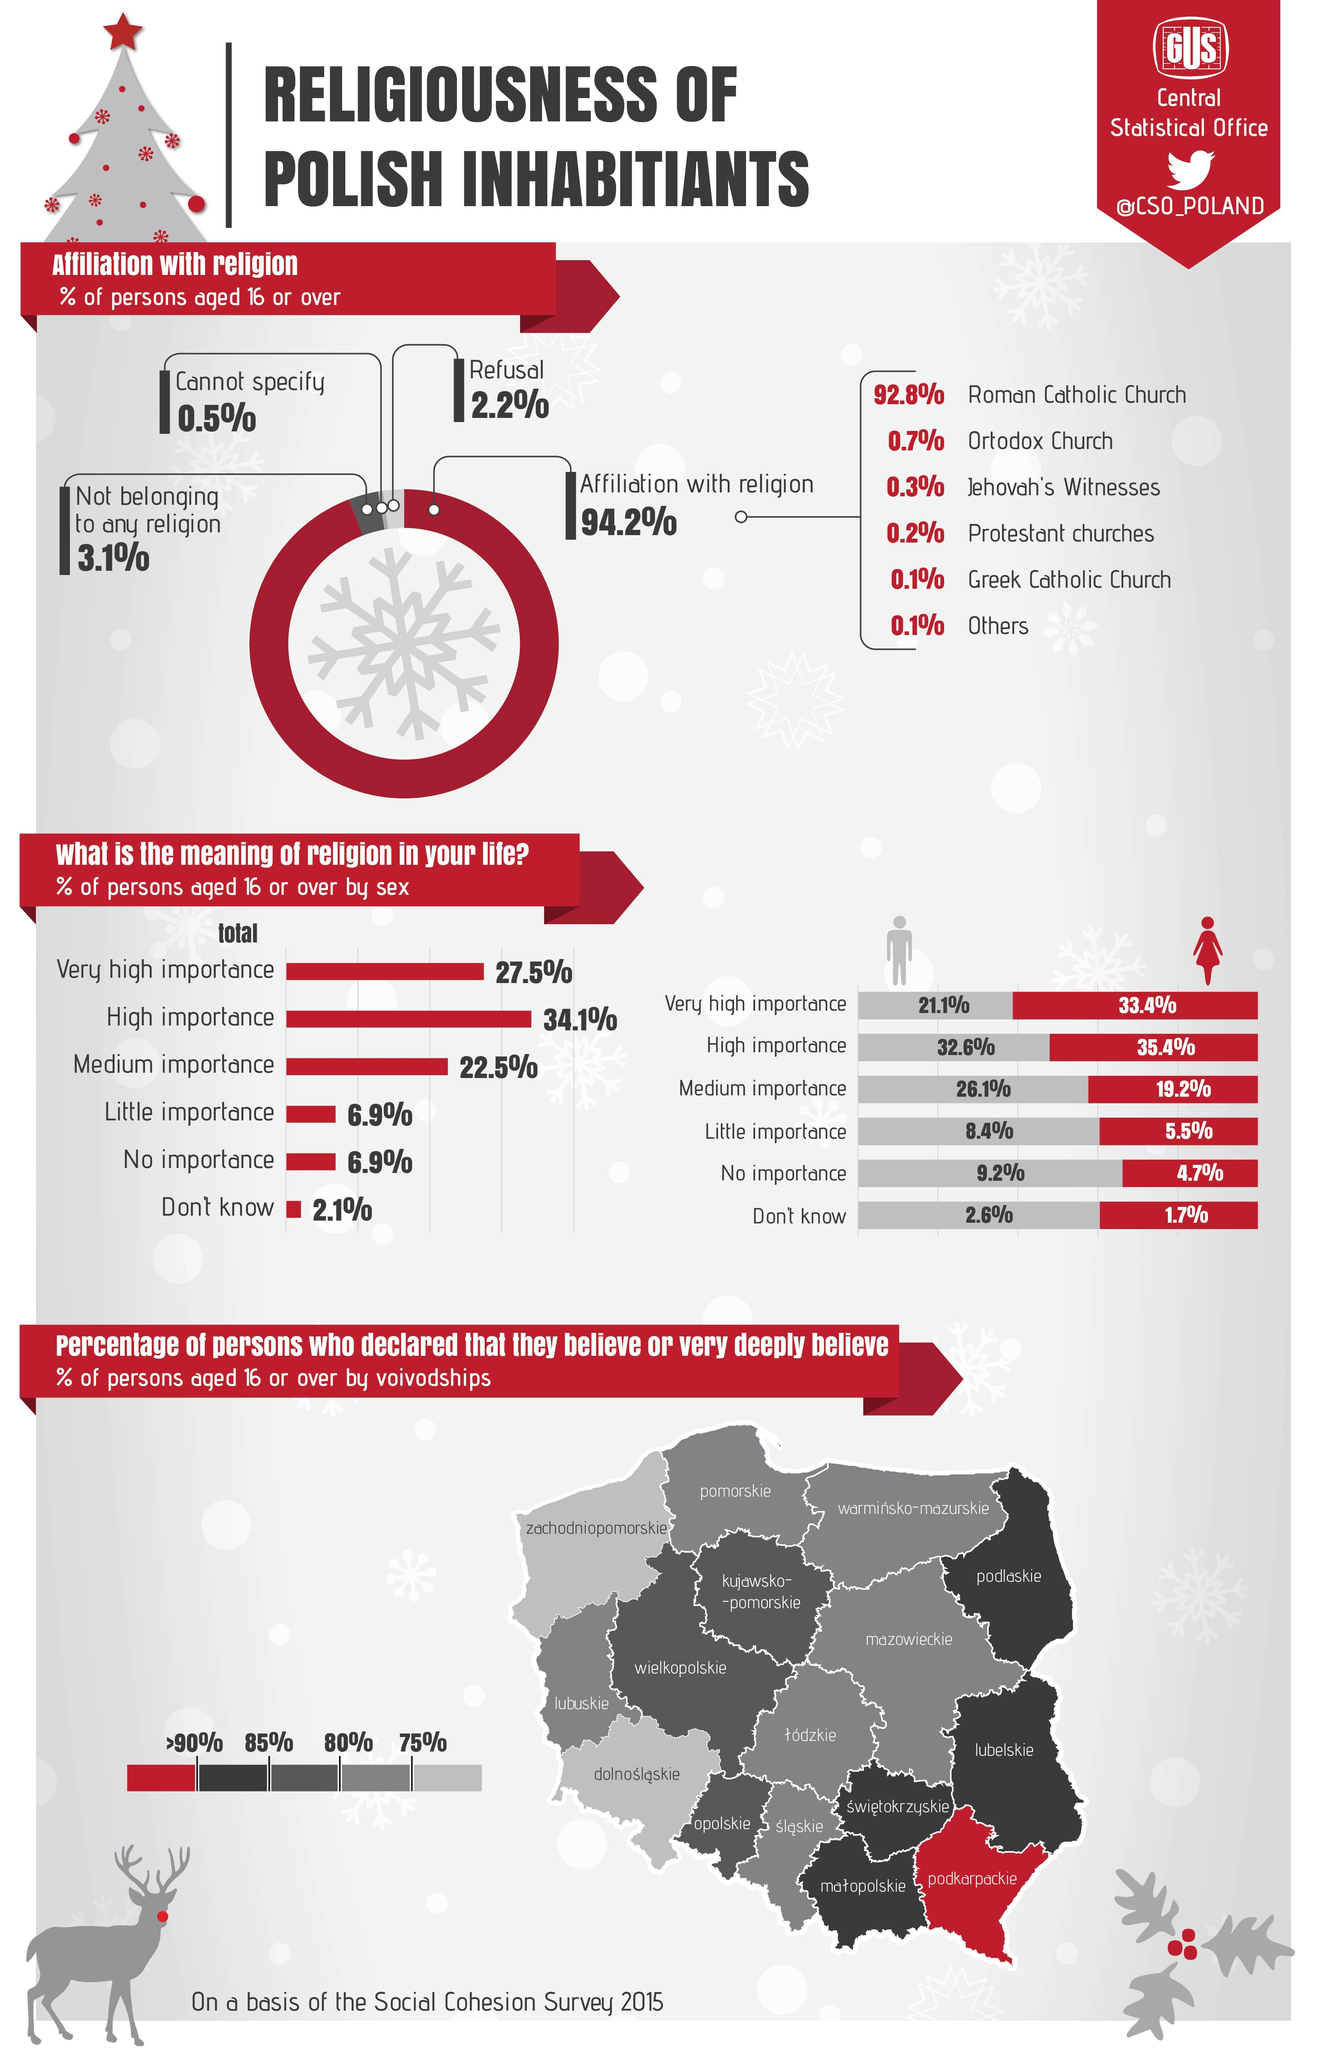Give some essential details in this illustration. According to a survey conducted in 2015, only 0.7% of persons aged 16 or over in Poland are affiliated with an orthodox religion. According to a 2015 survey in Poland, it was found that only 2.6% of males aged 16 or over did not know about religion. According to a 2015 survey in Poland, only 4.7% of females aged 16 or over gave no importance to religion. The Ortodox Church is the second famous religious church in Poland. According to the 2015 survey, only 8.4% of males aged 16 or over in Poland gave little importance to religion. 